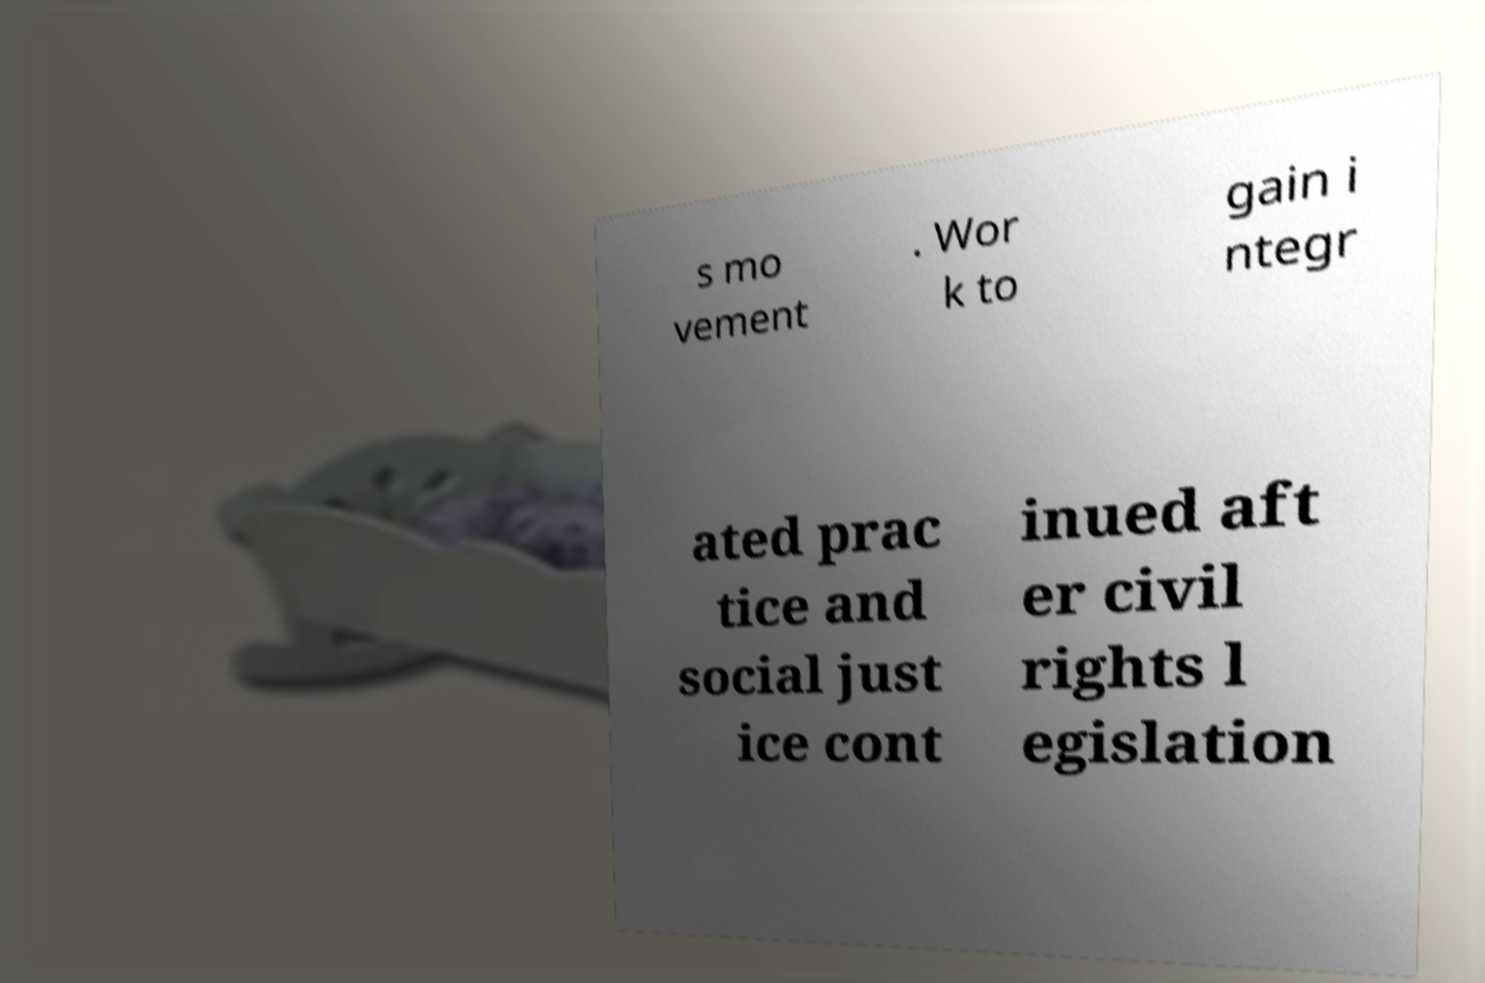For documentation purposes, I need the text within this image transcribed. Could you provide that? s mo vement . Wor k to gain i ntegr ated prac tice and social just ice cont inued aft er civil rights l egislation 